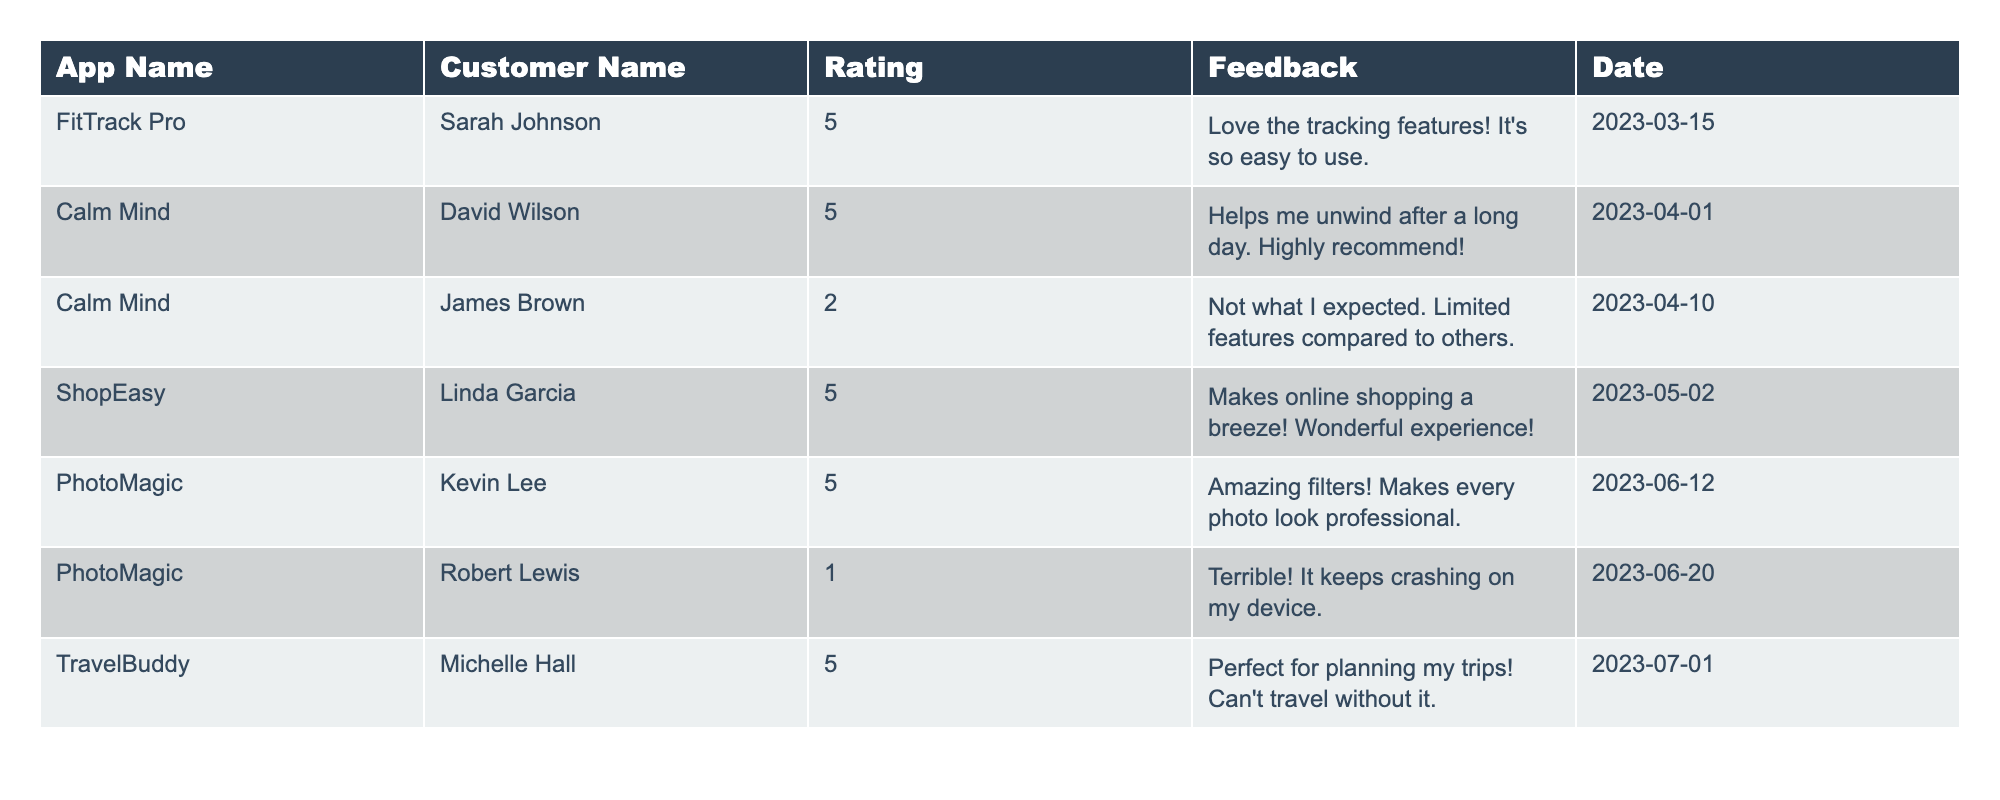What is the highest customer rating for the apps in the table? The highest customer rating listed in the table is 5, as seen in the rows for "FitTrack Pro," "Calm Mind," "ShopEasy," "PhotoMagic," and "TravelBuddy."
Answer: 5 Who provided feedback for "PhotoMagic"? The feedback for "PhotoMagic" comes from two customers: Kevin Lee with a rating of 5 and Robert Lewis with a rating of 1.
Answer: Kevin Lee and Robert Lewis How many apps received a rating of 2 or less? From the table, only one app, "Calm Mind," received a rating of 2, while "PhotoMagic" received a rating of 1, making it a total of 2 apps.
Answer: 2 What is the average rating of the apps in the table? To find the average, we add the ratings (5 + 5 + 2 + 5 + 5 + 1 + 5) = 28, then divide by the total number of apps (7) to get an average of 28/7 = 4.
Answer: 4 Did any customer give "ShopEasy" a rating lower than 5? There is no entry in the table for "ShopEasy" with a rating lower than 5; it is only rated 5 by Linda Garcia.
Answer: No Which customer gave the lowest rating and for what app? The lowest rating of 1 was given by Robert Lewis for the app "PhotoMagic."
Answer: Robert Lewis for "PhotoMagic" What was the average rating for the app "Calm Mind"? There are two ratings for "Calm Mind" (5 and 2). The average can be calculated by adding the ratings (5 + 2 = 7) and dividing by the count of ratings (2), which results in an average of 7/2 = 3.5.
Answer: 3.5 How many customers left feedback with a rating of 5? Referring to the table, there are four entries that have a rating of 5, from the apps "FitTrack Pro," "Calm Mind," "ShopEasy," "PhotoMagic," and "TravelBuddy."
Answer: 4 Is any app rated 1 by multiple customers? The table shows that "PhotoMagic" is the only app with a rating of 1, and it is only rated once by Robert Lewis. Therefore, no app received a rating of 1 from multiple customers.
Answer: No Which mobile app has the most positive feedback based on the rating? Based on the table, "FitTrack Pro," "Calm Mind," "ShopEasy," "PhotoMagic," and "TravelBuddy" all received the highest ratings of 5, indicating they have the most positive feedback.
Answer: 5 apps with 5 ratings 